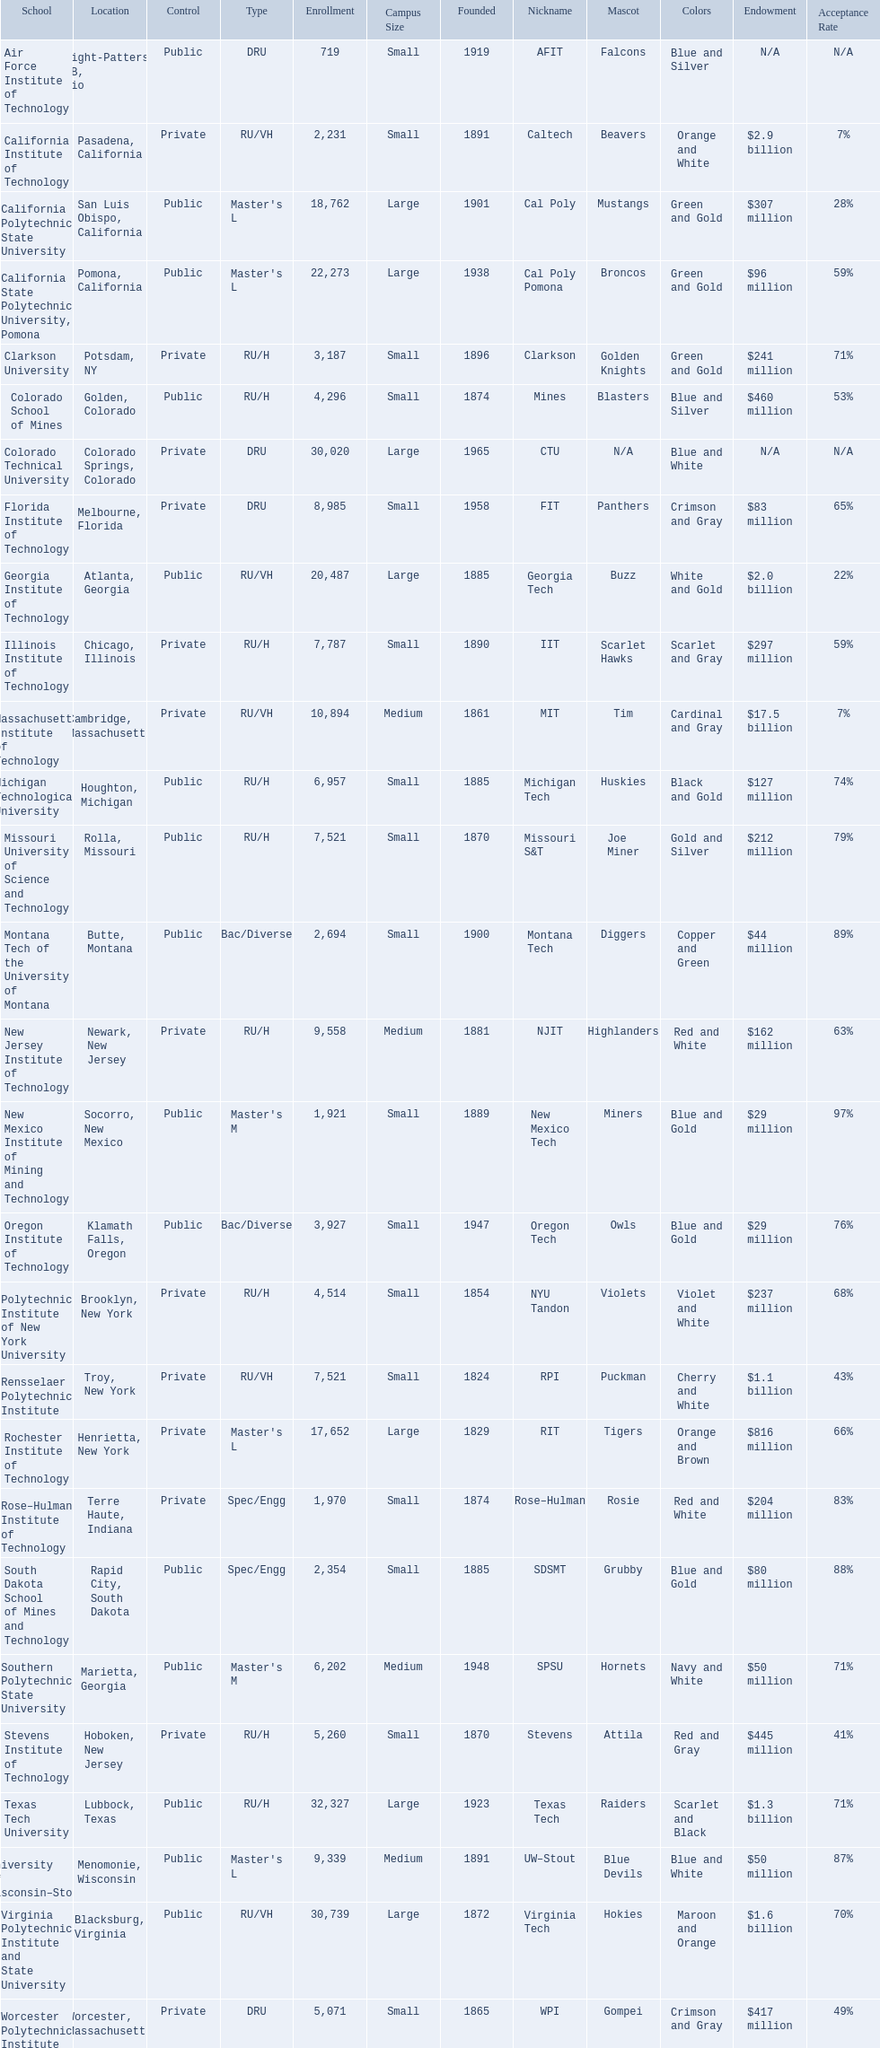What are all the schools? Air Force Institute of Technology, California Institute of Technology, California Polytechnic State University, California State Polytechnic University, Pomona, Clarkson University, Colorado School of Mines, Colorado Technical University, Florida Institute of Technology, Georgia Institute of Technology, Illinois Institute of Technology, Massachusetts Institute of Technology, Michigan Technological University, Missouri University of Science and Technology, Montana Tech of the University of Montana, New Jersey Institute of Technology, New Mexico Institute of Mining and Technology, Oregon Institute of Technology, Polytechnic Institute of New York University, Rensselaer Polytechnic Institute, Rochester Institute of Technology, Rose–Hulman Institute of Technology, South Dakota School of Mines and Technology, Southern Polytechnic State University, Stevens Institute of Technology, Texas Tech University, University of Wisconsin–Stout, Virginia Polytechnic Institute and State University, Worcester Polytechnic Institute. What is the enrollment of each school? 719, 2,231, 18,762, 22,273, 3,187, 4,296, 30,020, 8,985, 20,487, 7,787, 10,894, 6,957, 7,521, 2,694, 9,558, 1,921, 3,927, 4,514, 7,521, 17,652, 1,970, 2,354, 6,202, 5,260, 32,327, 9,339, 30,739, 5,071. And which school had the highest enrollment? Texas Tech University. 